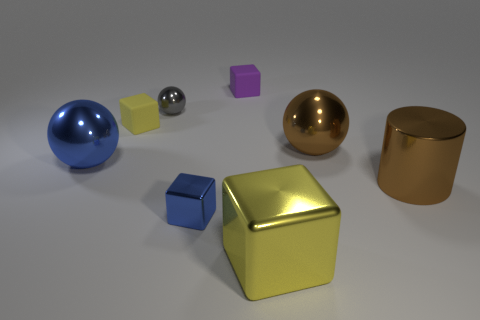Subtract all small blue shiny blocks. How many blocks are left? 3 Add 2 purple rubber objects. How many objects exist? 10 Subtract 1 balls. How many balls are left? 2 Subtract all yellow cubes. How many cubes are left? 2 Subtract all cylinders. How many objects are left? 7 Subtract all purple cylinders. How many brown balls are left? 1 Subtract all large blue objects. Subtract all small rubber objects. How many objects are left? 5 Add 3 small yellow rubber objects. How many small yellow rubber objects are left? 4 Add 6 big brown spheres. How many big brown spheres exist? 7 Subtract 0 yellow spheres. How many objects are left? 8 